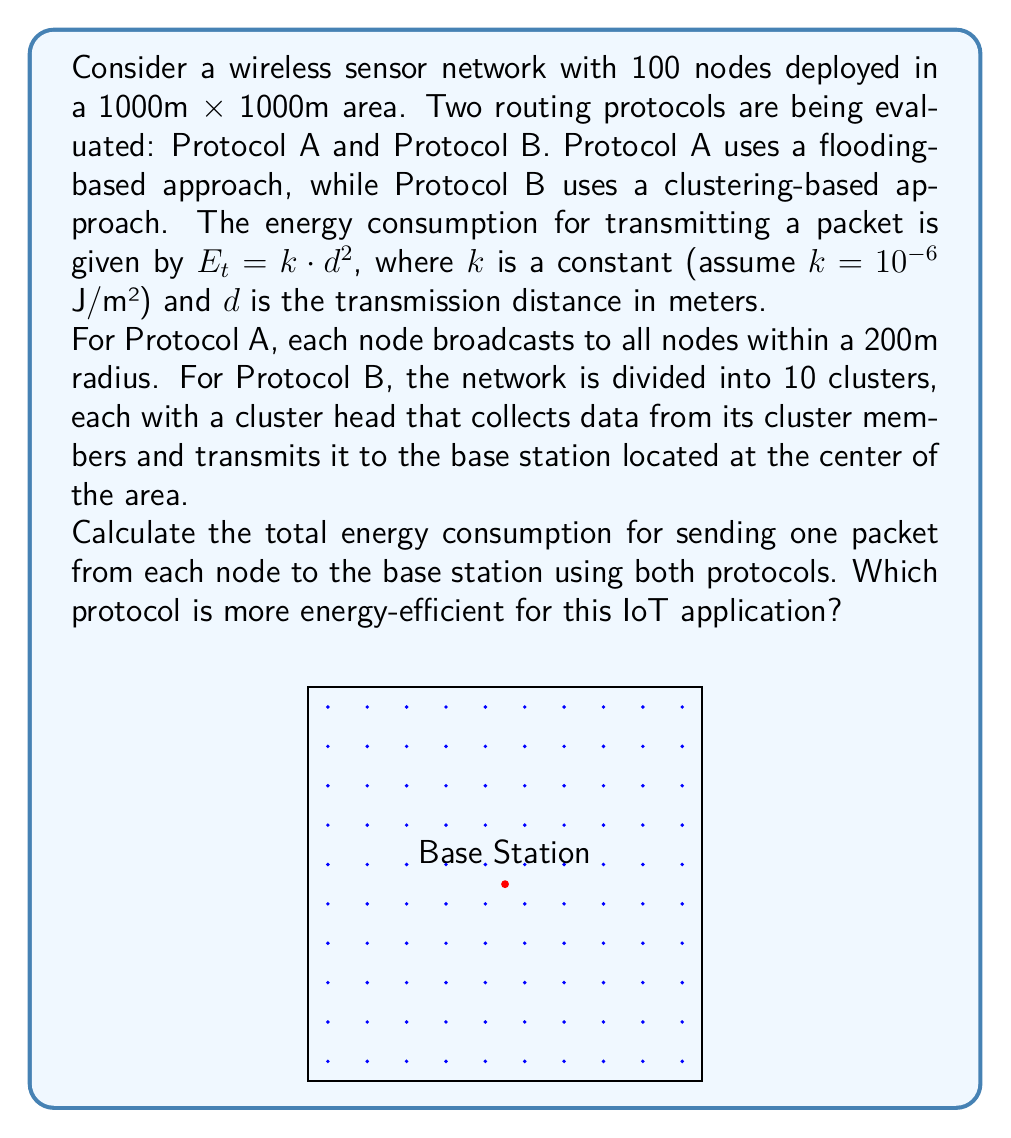Show me your answer to this math problem. Let's approach this step-by-step:

1) For Protocol A (Flooding):
   - Each node broadcasts to all nodes within 200m.
   - Energy consumption per node: $E_A = k \cdot 200^2 = 10^{-6} \cdot 200^2 = 0.04$ J
   - Total energy consumption: $E_{total_A} = 100 \cdot 0.04 = 4$ J

2) For Protocol B (Clustering):
   - We need to calculate:
     a) Energy for nodes to send to cluster heads
     b) Energy for cluster heads to send to base station

   a) For nodes to cluster heads:
      - Average cluster size: $1000 \text{ m} / \sqrt{10} \approx 316$ m
      - Average distance to cluster head: $316 / 2 \approx 158$ m
      - Energy per node: $E_{node} = k \cdot 158^2 \approx 0.025$ J
      - Total for 90 non-cluster head nodes: $90 \cdot 0.025 = 2.25$ J

   b) For cluster heads to base station:
      - Maximum distance to base station: $\sqrt{2} \cdot 500 \approx 707$ m
      - Energy per cluster head: $E_{CH} = k \cdot 707^2 \approx 0.5$ J
      - Total for 10 cluster heads: $10 \cdot 0.5 = 5$ J

   Total energy consumption for Protocol B:
   $E_{total_B} = 2.25 + 5 = 7.25$ J

3) Comparing the two protocols:
   Protocol A: 4 J
   Protocol B: 7.25 J

Therefore, Protocol A is more energy-efficient for this specific scenario.
Answer: Protocol A (4 J) is more energy-efficient than Protocol B (7.25 J). 